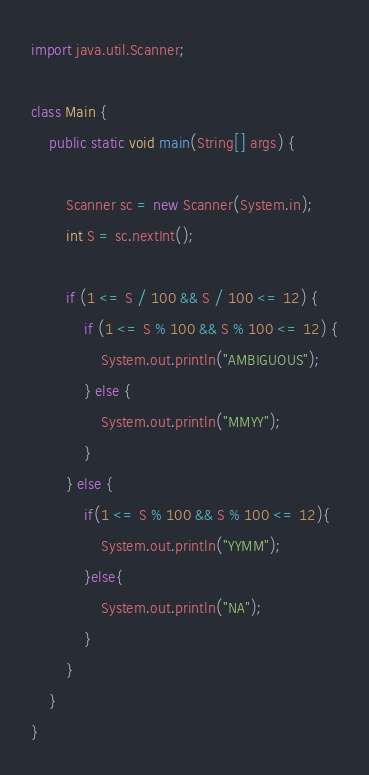<code> <loc_0><loc_0><loc_500><loc_500><_Java_>import java.util.Scanner;

class Main {
    public static void main(String[] args) {

        Scanner sc = new Scanner(System.in);
        int S = sc.nextInt();

        if (1 <= S / 100 && S / 100 <= 12) {
            if (1 <= S % 100 && S % 100 <= 12) {
                System.out.println("AMBIGUOUS");
            } else {
                System.out.println("MMYY");
            }
        } else {
            if(1 <= S % 100 && S % 100 <= 12){
                System.out.println("YYMM");
            }else{
                System.out.println("NA");
            }
        }
    }
}
</code> 